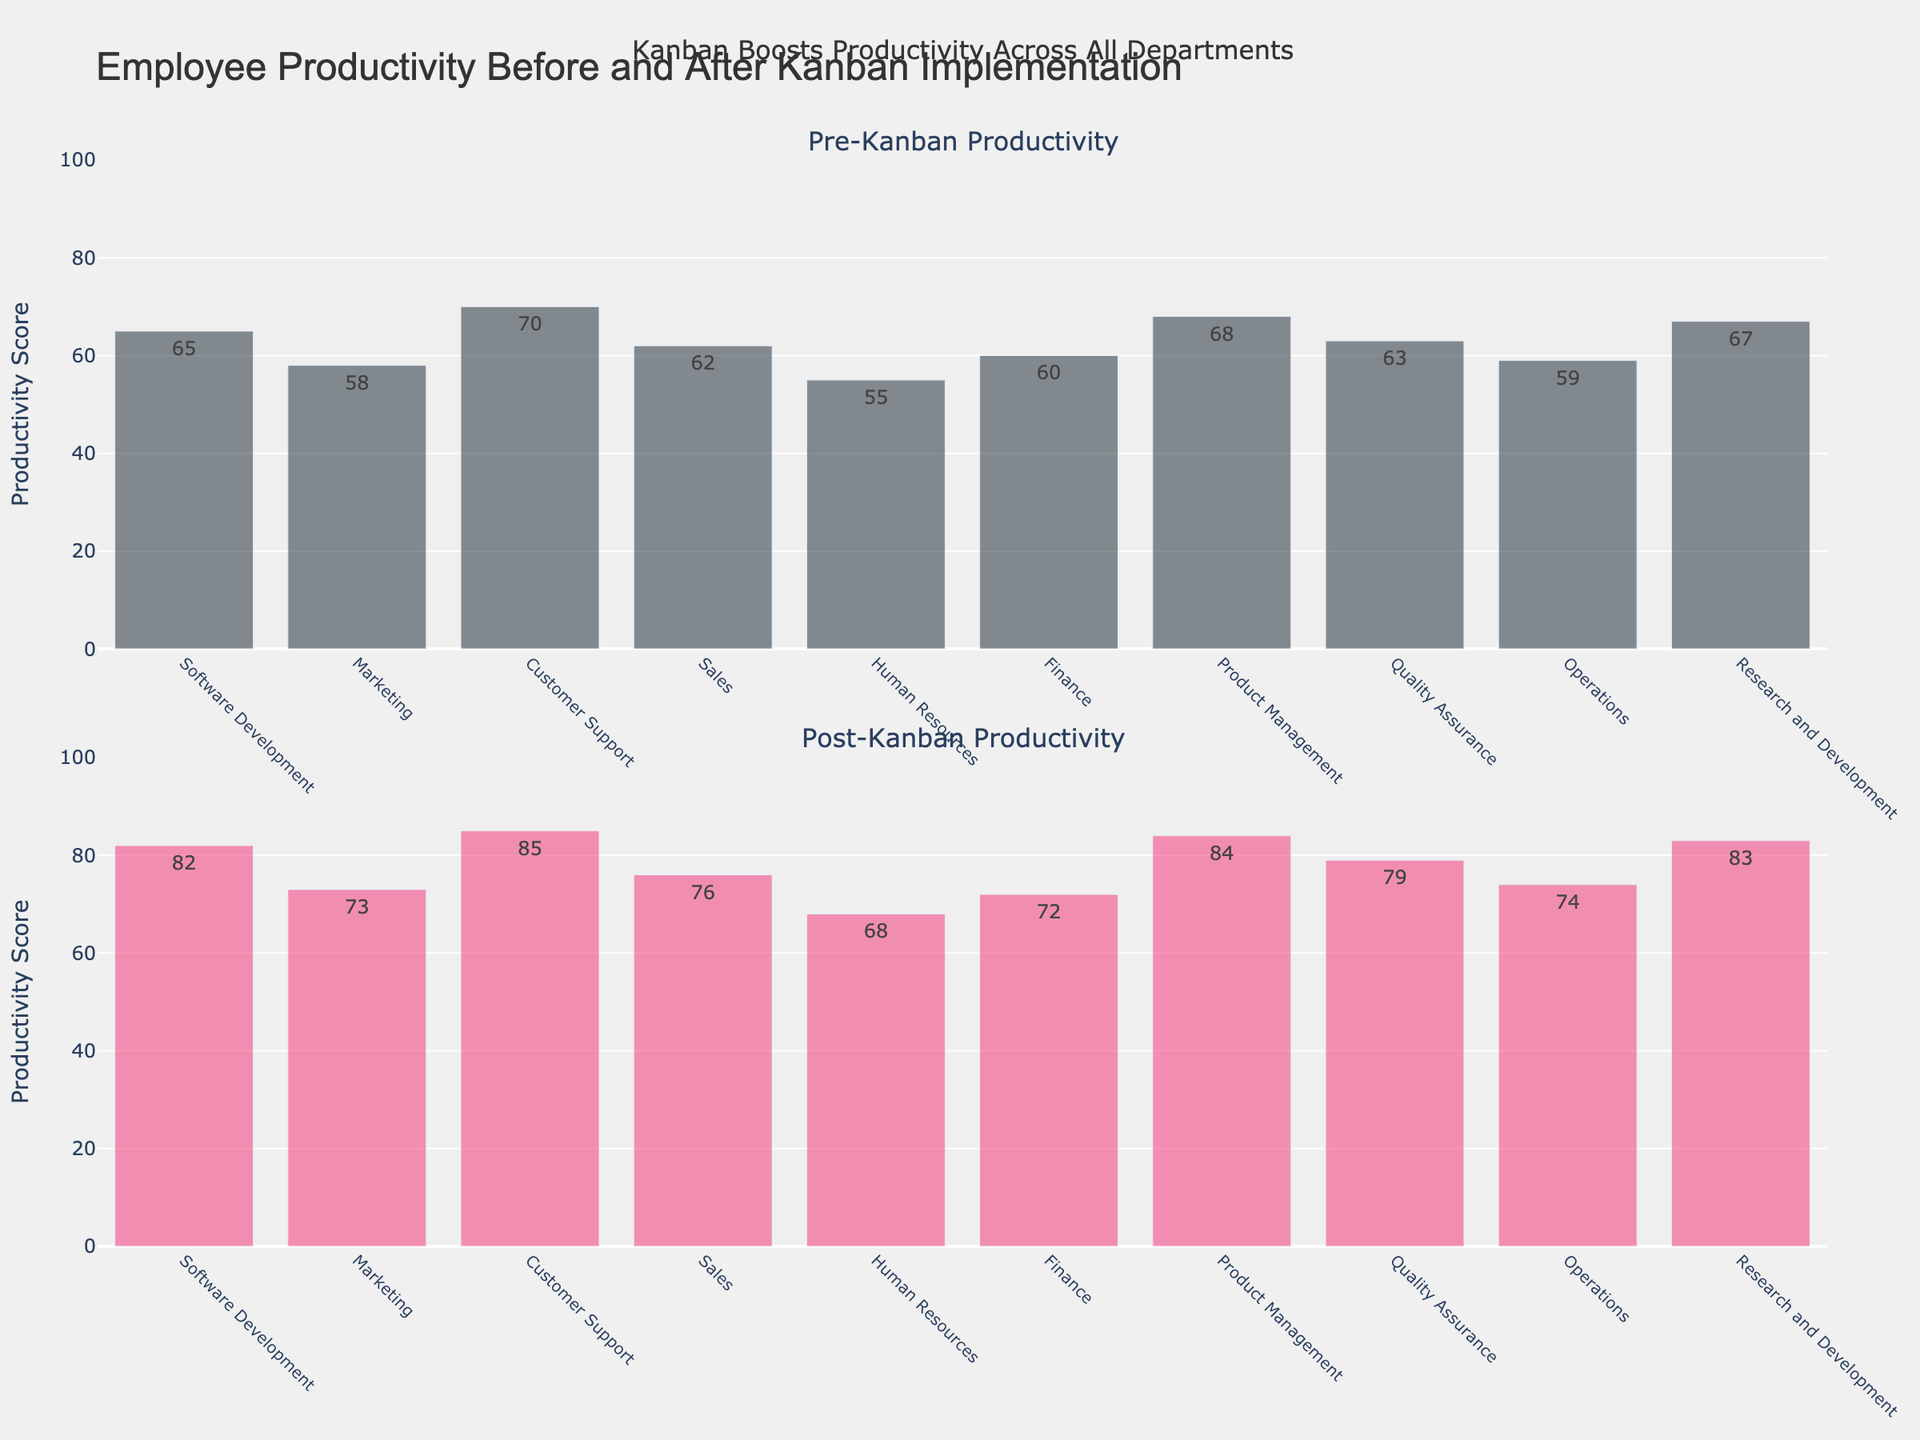What is the title of the plot? The title of the plot is displayed at the top and reads "Employee Productivity Before and After Kanban Implementation".
Answer: "Employee Productivity Before and After Kanban Implementation" What does the y-axis represent in both subplots? The y-axis in both subplots represents the "Productivity Score". This is shown by the y-axis title which remains consistent across both subplots.
Answer: Productivity Score Which department had the highest productivity score before Kanban implementation? To find the highest pre-Kanban productivity score, we look at the first subplot. The highest bar corresponds to the Customer Support department with a score of 70.
Answer: Customer Support How much did the productivity score for the Marketing department increase after Kanban implementation? The pre-Kanban score for Marketing is 58 and the post-Kanban score is 73. The increase is calculated as 73 - 58.
Answer: 15 Which department showed the least improvement in productivity after Kanban implementation? By comparing the differences between pre-Kanban and post-Kanban scores for each department, Human Resources showed the least improvement with an increase of 13 (68 - 55).
Answer: Human Resources What is the average productivity score for all departments before Kanban was implemented? Summing up all the pre-Kanban scores and dividing by the number of departments: (65 + 58 + 70 + 62 + 55 + 60 + 68 + 63 + 59 + 67) / 10 = 62.7.
Answer: 62.7 Which department had the highest productivity score after Kanban implementation? In the second subplot, the highest bar corresponds to the Customer Support department with a score of 85.
Answer: Customer Support How does the average productivity score after Kanban implementation compare to the average before Kanban implementation? The average post-Kanban score is calculated as (82 + 73 + 85 + 76 + 68 + 72 + 84 + 79 + 74 + 83) / 10 = 77.6. Comparing both averages, the pre-Kanban average was 62.7 and the post-Kanban average is 77.6. The increase is 77.6 - 62.7.
Answer: Increased by 14.9 Is the productivity score for Product Management higher than Operations both before and after Kanban implementation? Comparing pre-Kanban scores: Product Management (68) > Operations (59). Comparing post-Kanban scores: Product Management (84) > Operations (74).
Answer: Yes What major insight can be drawn from the subplots about Kanban's impact on productivity in the company? The major insight is that Kanban implementation has increased productivity across all departments, as visible from the higher bars in the post-Kanban subplot compared to the pre-Kanban subplot for each department.
Answer: Increased productivity across all departments 